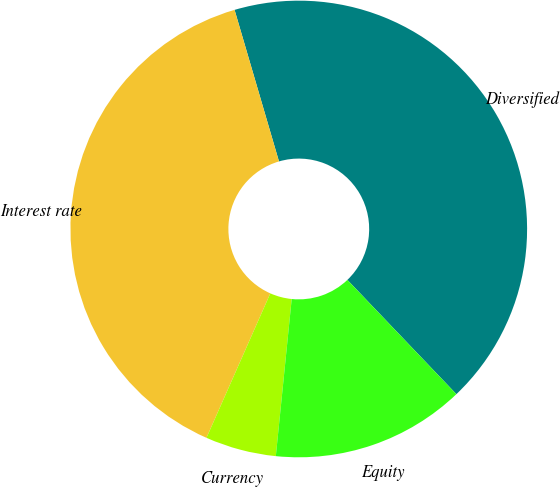Convert chart. <chart><loc_0><loc_0><loc_500><loc_500><pie_chart><fcel>Diversified<fcel>Interest rate<fcel>Currency<fcel>Equity<nl><fcel>42.41%<fcel>38.84%<fcel>5.02%<fcel>13.73%<nl></chart> 